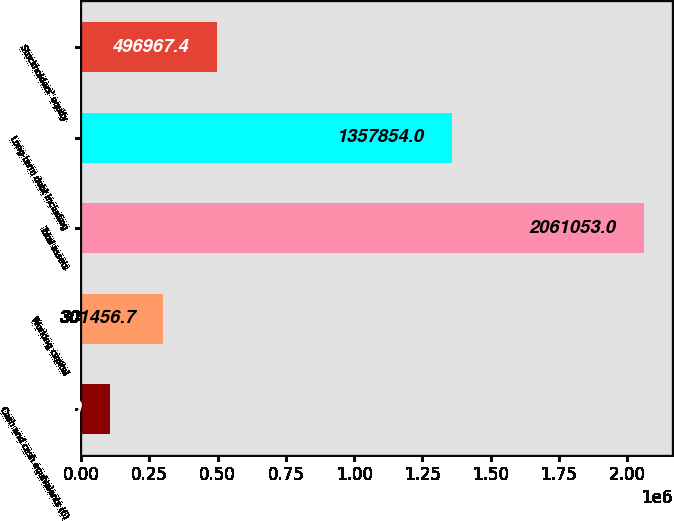Convert chart. <chart><loc_0><loc_0><loc_500><loc_500><bar_chart><fcel>Cash and cash equivalents (6)<fcel>Working capital<fcel>Total assets<fcel>Long-term debt including<fcel>Stockholders' equity<nl><fcel>105946<fcel>301457<fcel>2.06105e+06<fcel>1.35785e+06<fcel>496967<nl></chart> 